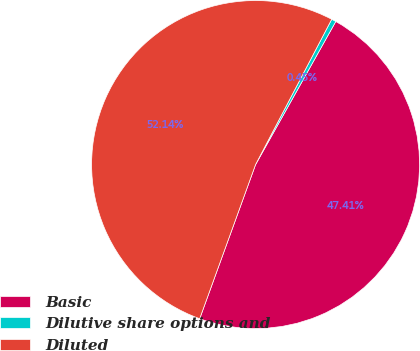Convert chart. <chart><loc_0><loc_0><loc_500><loc_500><pie_chart><fcel>Basic<fcel>Dilutive share options and<fcel>Diluted<nl><fcel>47.41%<fcel>0.45%<fcel>52.15%<nl></chart> 